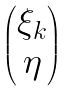Convert formula to latex. <formula><loc_0><loc_0><loc_500><loc_500>\begin{pmatrix} \xi _ { k } \\ \eta \end{pmatrix}</formula> 